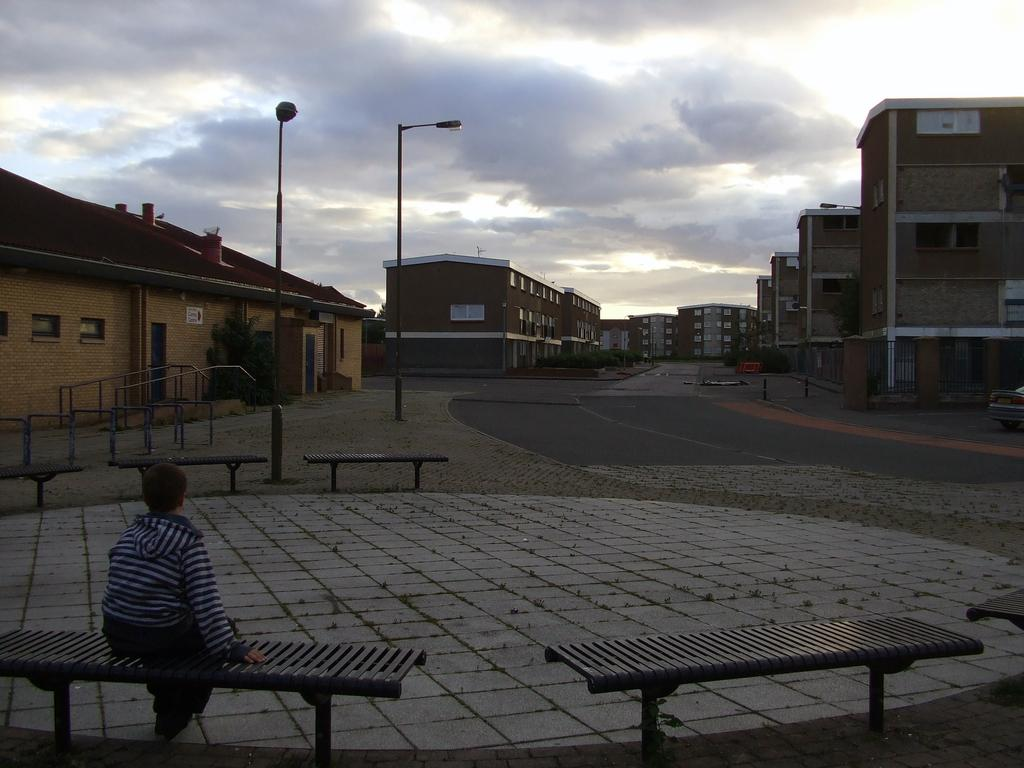What type of seating is present in the image? There are benches in the image. Is anyone using the benches? Yes, a person is sitting on one of the benches. What can be seen in the distance behind the benches? There is a road, buildings, two poles, and the sky visible in the background of the image. What is the temperature of the person sitting on the bench in the image? The temperature of the person sitting on the bench cannot be determined from the image. Can you tell me how the person sitting on the bench feels about themselves? There is no information in the image to determine how the person feels about themselves. 